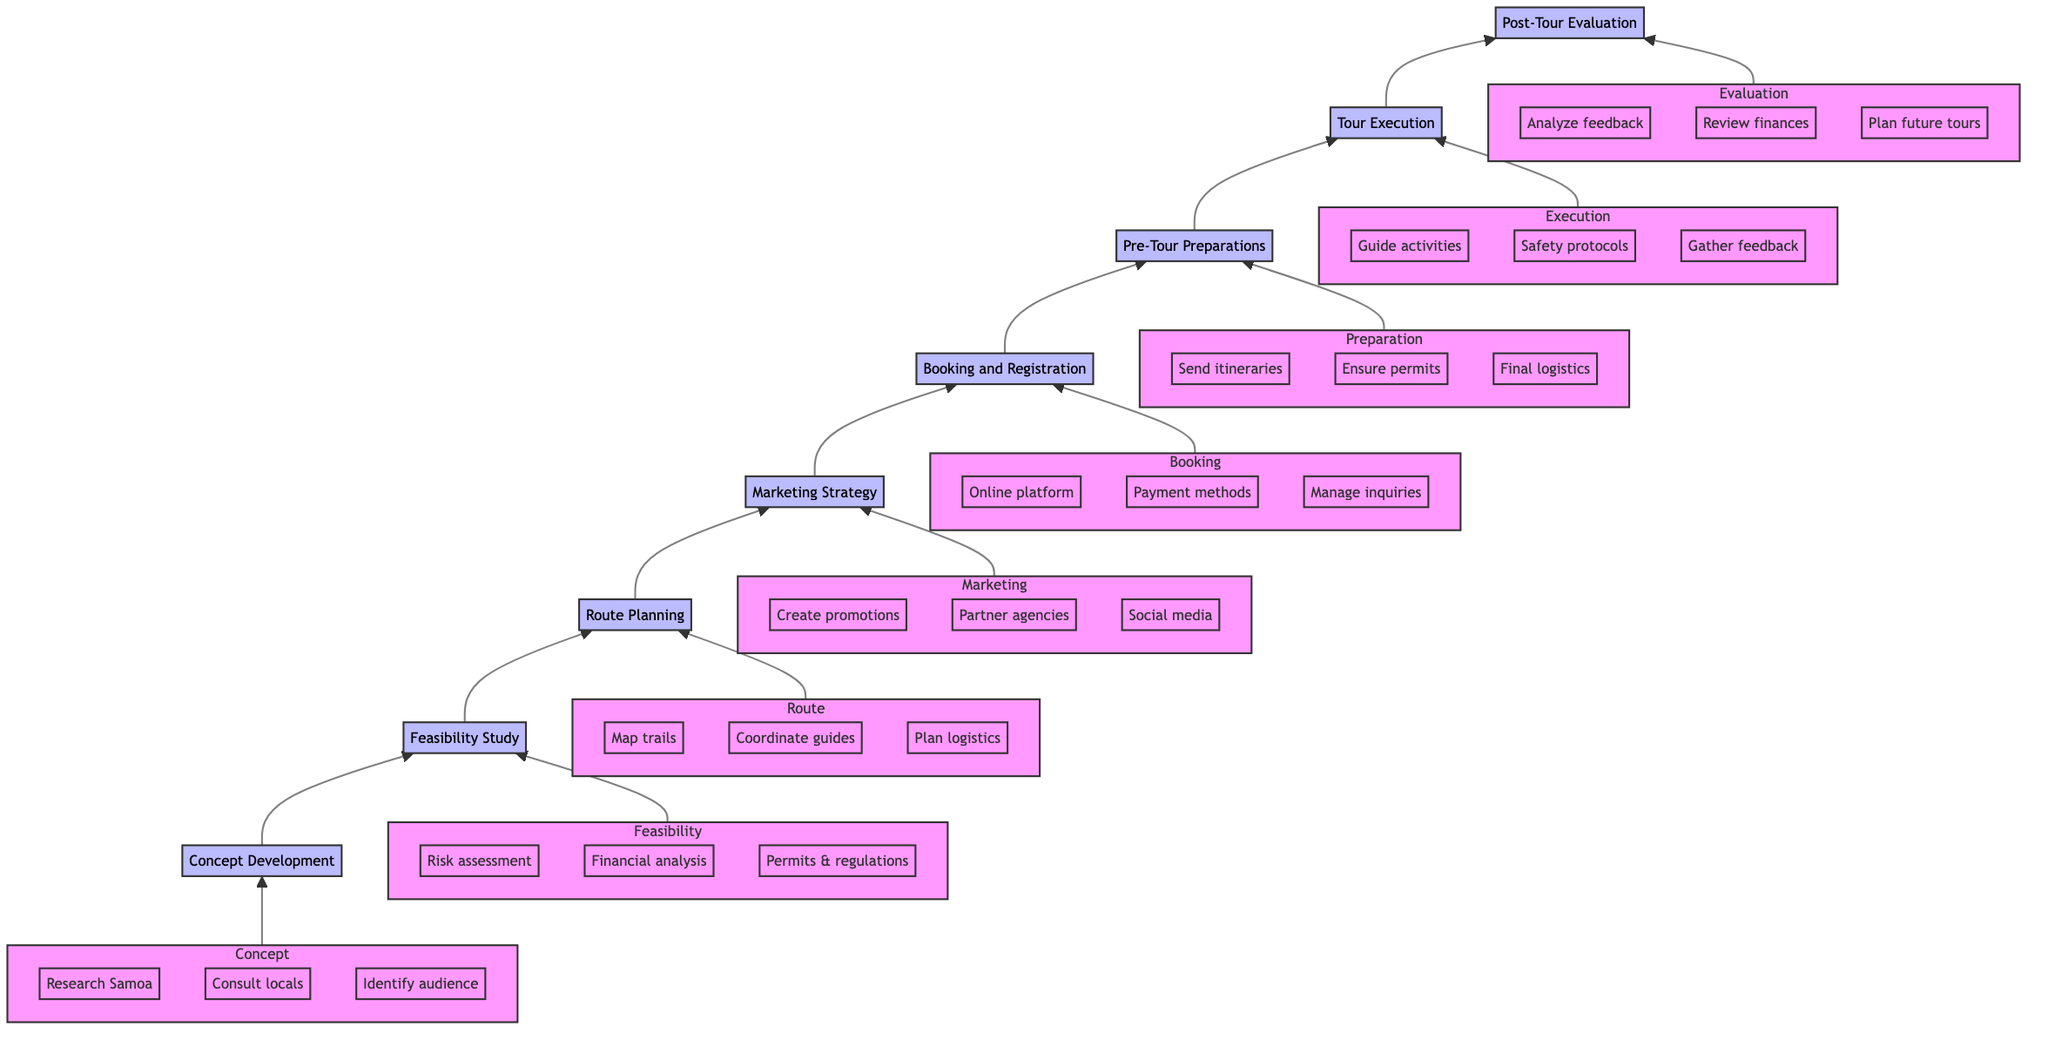What is the first stage of the tour planning process? The flowchart starts with the stage labeled "Concept Development," which is the first node in the diagram.
Answer: Concept Development How many stages are there in total? By counting the nodes in the diagram, we find there are eight distinct stages, starting from Concept Development and ending with Post-Tour Evaluation.
Answer: Eight Which stage comes directly after Route Planning? The diagram shows that the stage following "Route Planning" is "Marketing Strategy," as it flows directly upward from the Route Planning node.
Answer: Marketing Strategy What key action is associated with Pre-Tour Preparations? The key action listed under "Pre-Tour Preparations" is sending out detailed itineraries to participants, which is one of the main actions in this stage.
Answer: Send out detailed itineraries Which stages involve risk assessments or safety protocols? "Feasibility Study" is the stage where risk assessments are conducted, and "Tour Execution" is the stage where safety protocols are followed during the tour.
Answer: Feasibility Study and Tour Execution Identify the last stage of the planning process? The last stage in the flowchart is "Post-Tour Evaluation," which is the topmost node and concludes the process of planning and executing the adventure tour.
Answer: Post-Tour Evaluation What key action is included in the Marketing Strategy stage? One of the key actions in the "Marketing Strategy" stage is creating promotional materials that highlight unique experiences to attract adventure tourists.
Answer: Create promotional materials How does the flow of the diagram represent the concept of planning? The diagram displays a linear flow from bottom to top, showcasing how each stage builds on the previous one systematically, starting from concept development and progressing through feasibility, planning, and execution to evaluation, demonstrating a structured planning process.
Answer: Structured planning process 